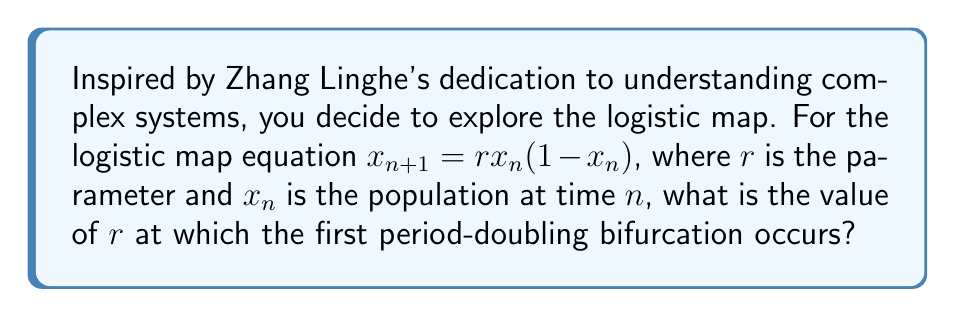Could you help me with this problem? To find the value of $r$ for the first period-doubling bifurcation, we need to follow these steps:

1) The logistic map has a fixed point when $x_{n+1} = x_n$. Let's call this fixed point $x^*$.

2) Substituting into the logistic equation:
   $x^* = rx^*(1-x^*)$

3) Solving this equation:
   $x^* = 0$ or $x^* = 1 - \frac{1}{r}$

4) The non-zero fixed point $x^* = 1 - \frac{1}{r}$ is stable when $|\frac{d}{dx}(rx(1-x))| < 1$ at $x = x^*$.

5) Calculating the derivative:
   $\frac{d}{dx}(rx(1-x)) = r(1-2x)$

6) Evaluating at $x^*$:
   $|r(1-2(1-\frac{1}{r}))| = |r(1-2+\frac{2}{r})| = |2-r| < 1$

7) This inequality is satisfied when $1 < r < 3$.

8) The first period-doubling bifurcation occurs when this fixed point becomes unstable, which happens when $r = 3$.

Therefore, the value of $r$ at which the first period-doubling bifurcation occurs is 3.
Answer: $r = 3$ 